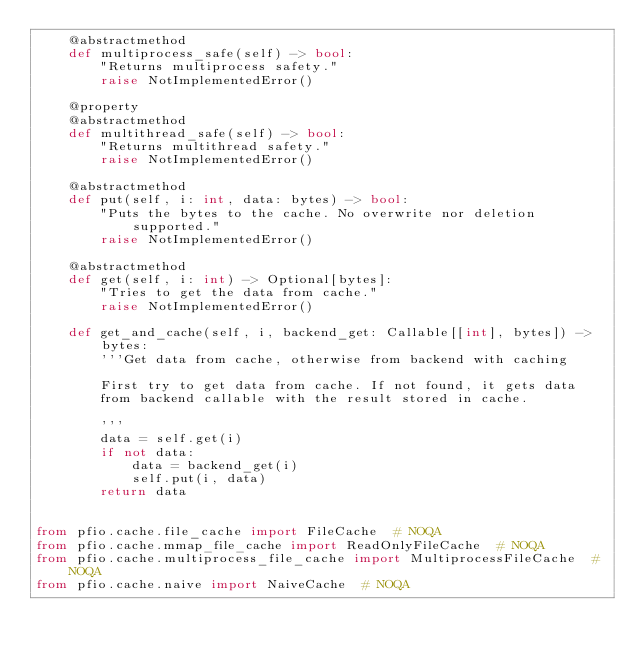<code> <loc_0><loc_0><loc_500><loc_500><_Python_>    @abstractmethod
    def multiprocess_safe(self) -> bool:
        "Returns multiprocess safety."
        raise NotImplementedError()

    @property
    @abstractmethod
    def multithread_safe(self) -> bool:
        "Returns multithread safety."
        raise NotImplementedError()

    @abstractmethod
    def put(self, i: int, data: bytes) -> bool:
        "Puts the bytes to the cache. No overwrite nor deletion supported."
        raise NotImplementedError()

    @abstractmethod
    def get(self, i: int) -> Optional[bytes]:
        "Tries to get the data from cache."
        raise NotImplementedError()

    def get_and_cache(self, i, backend_get: Callable[[int], bytes]) -> bytes:
        '''Get data from cache, otherwise from backend with caching

        First try to get data from cache. If not found, it gets data
        from backend callable with the result stored in cache.

        '''
        data = self.get(i)
        if not data:
            data = backend_get(i)
            self.put(i, data)
        return data


from pfio.cache.file_cache import FileCache  # NOQA
from pfio.cache.mmap_file_cache import ReadOnlyFileCache  # NOQA
from pfio.cache.multiprocess_file_cache import MultiprocessFileCache  # NOQA
from pfio.cache.naive import NaiveCache  # NOQA
</code> 